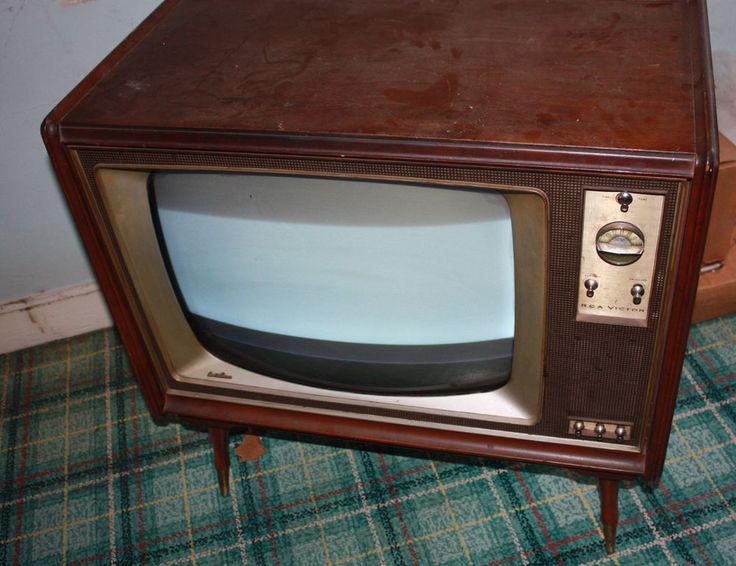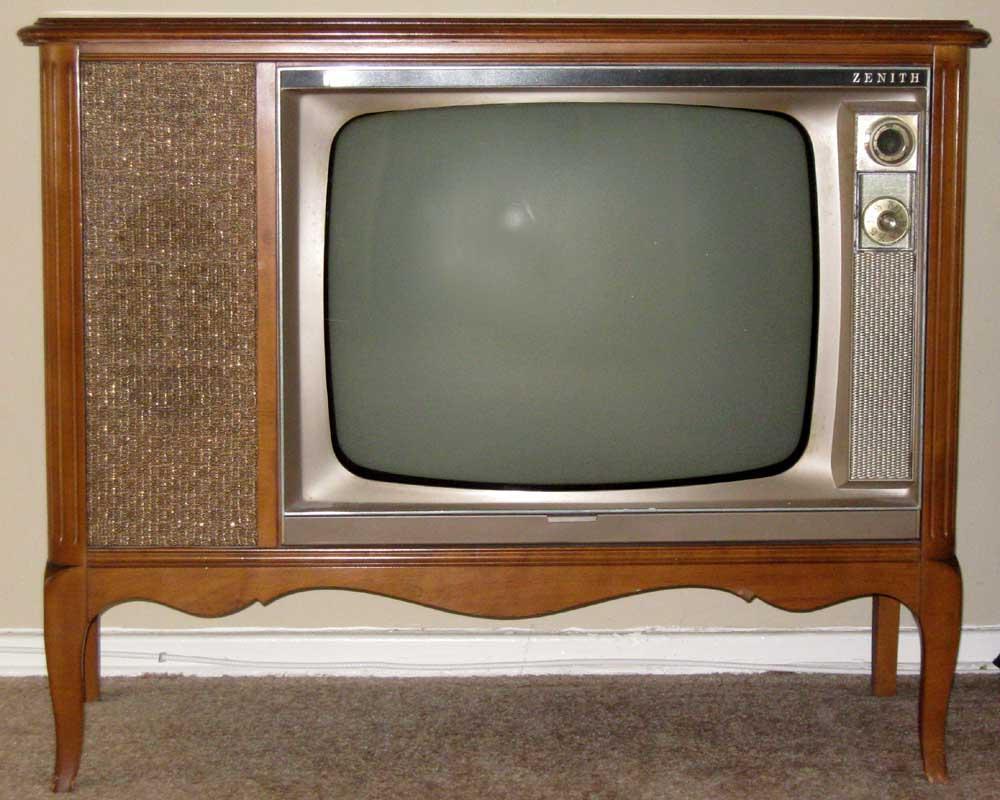The first image is the image on the left, the second image is the image on the right. Assess this claim about the two images: "There are exactly two knobs one the television in the image on the right.". Correct or not? Answer yes or no. Yes. The first image is the image on the left, the second image is the image on the right. For the images displayed, is the sentence "One of the TV sets does not have legs under it." factually correct? Answer yes or no. No. 